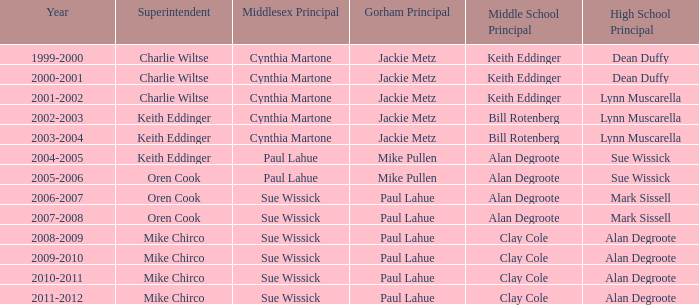How many high school principals were there in 2000-2001? Dean Duffy. 